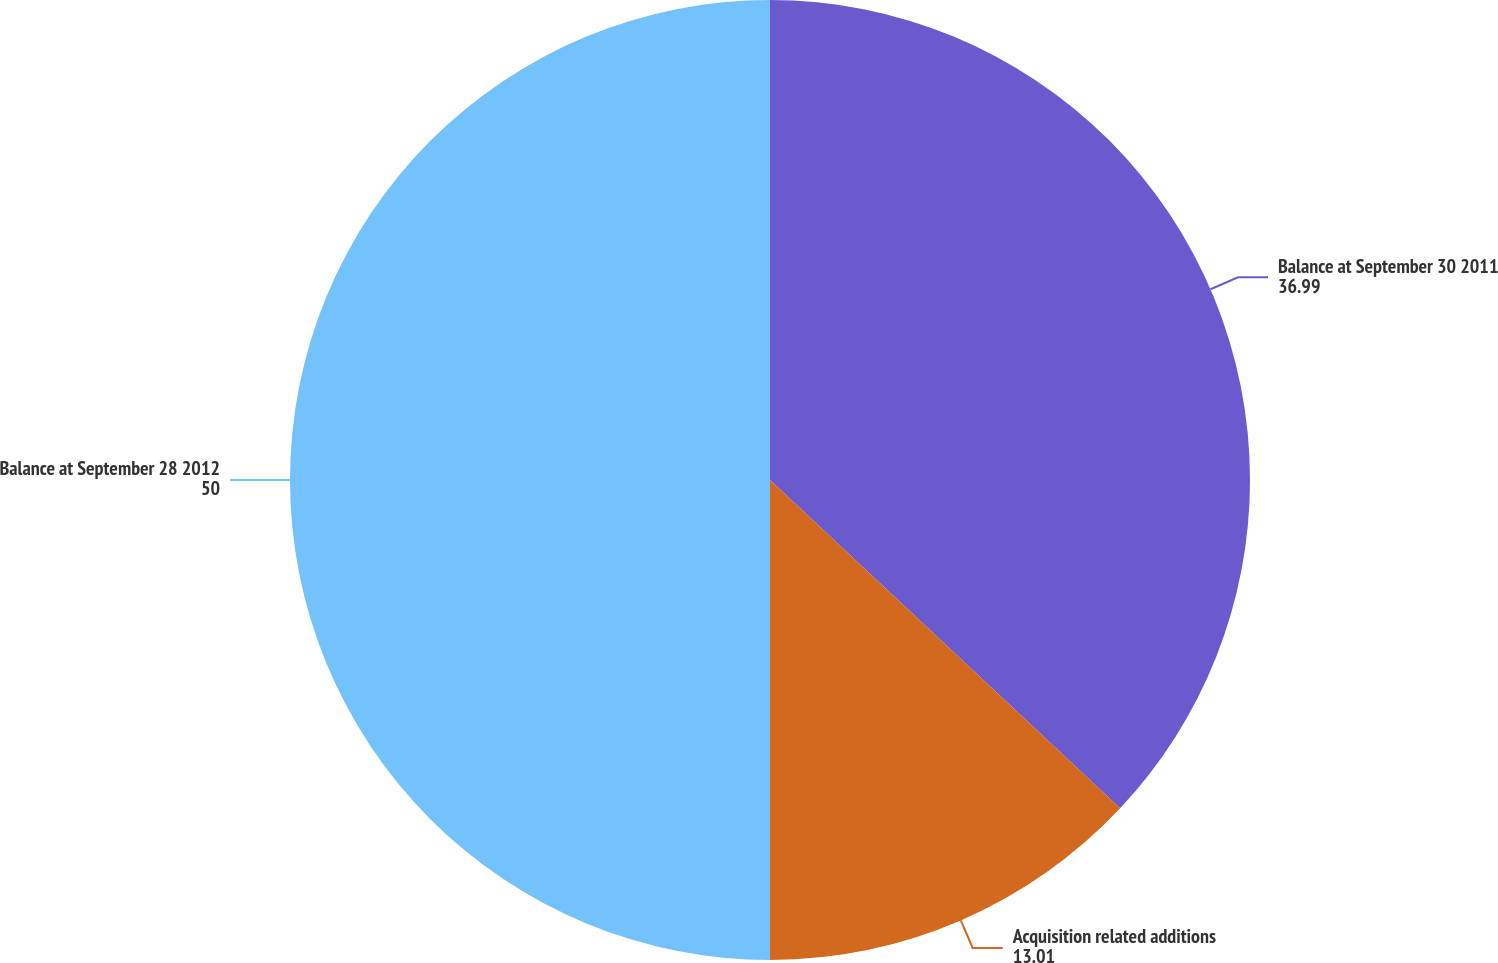Convert chart. <chart><loc_0><loc_0><loc_500><loc_500><pie_chart><fcel>Balance at September 30 2011<fcel>Acquisition related additions<fcel>Balance at September 28 2012<nl><fcel>36.99%<fcel>13.01%<fcel>50.0%<nl></chart> 